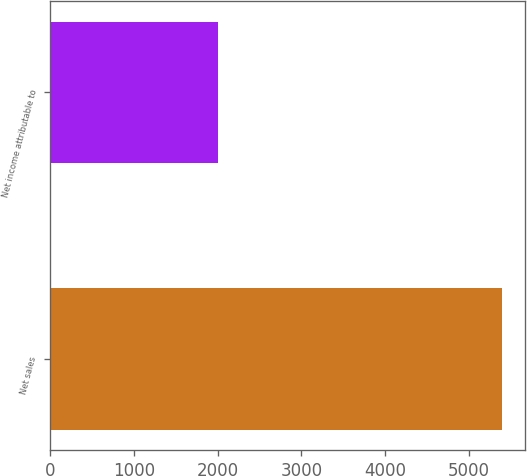Convert chart to OTSL. <chart><loc_0><loc_0><loc_500><loc_500><bar_chart><fcel>Net sales<fcel>Net income attributable to<nl><fcel>5395<fcel>2008<nl></chart> 